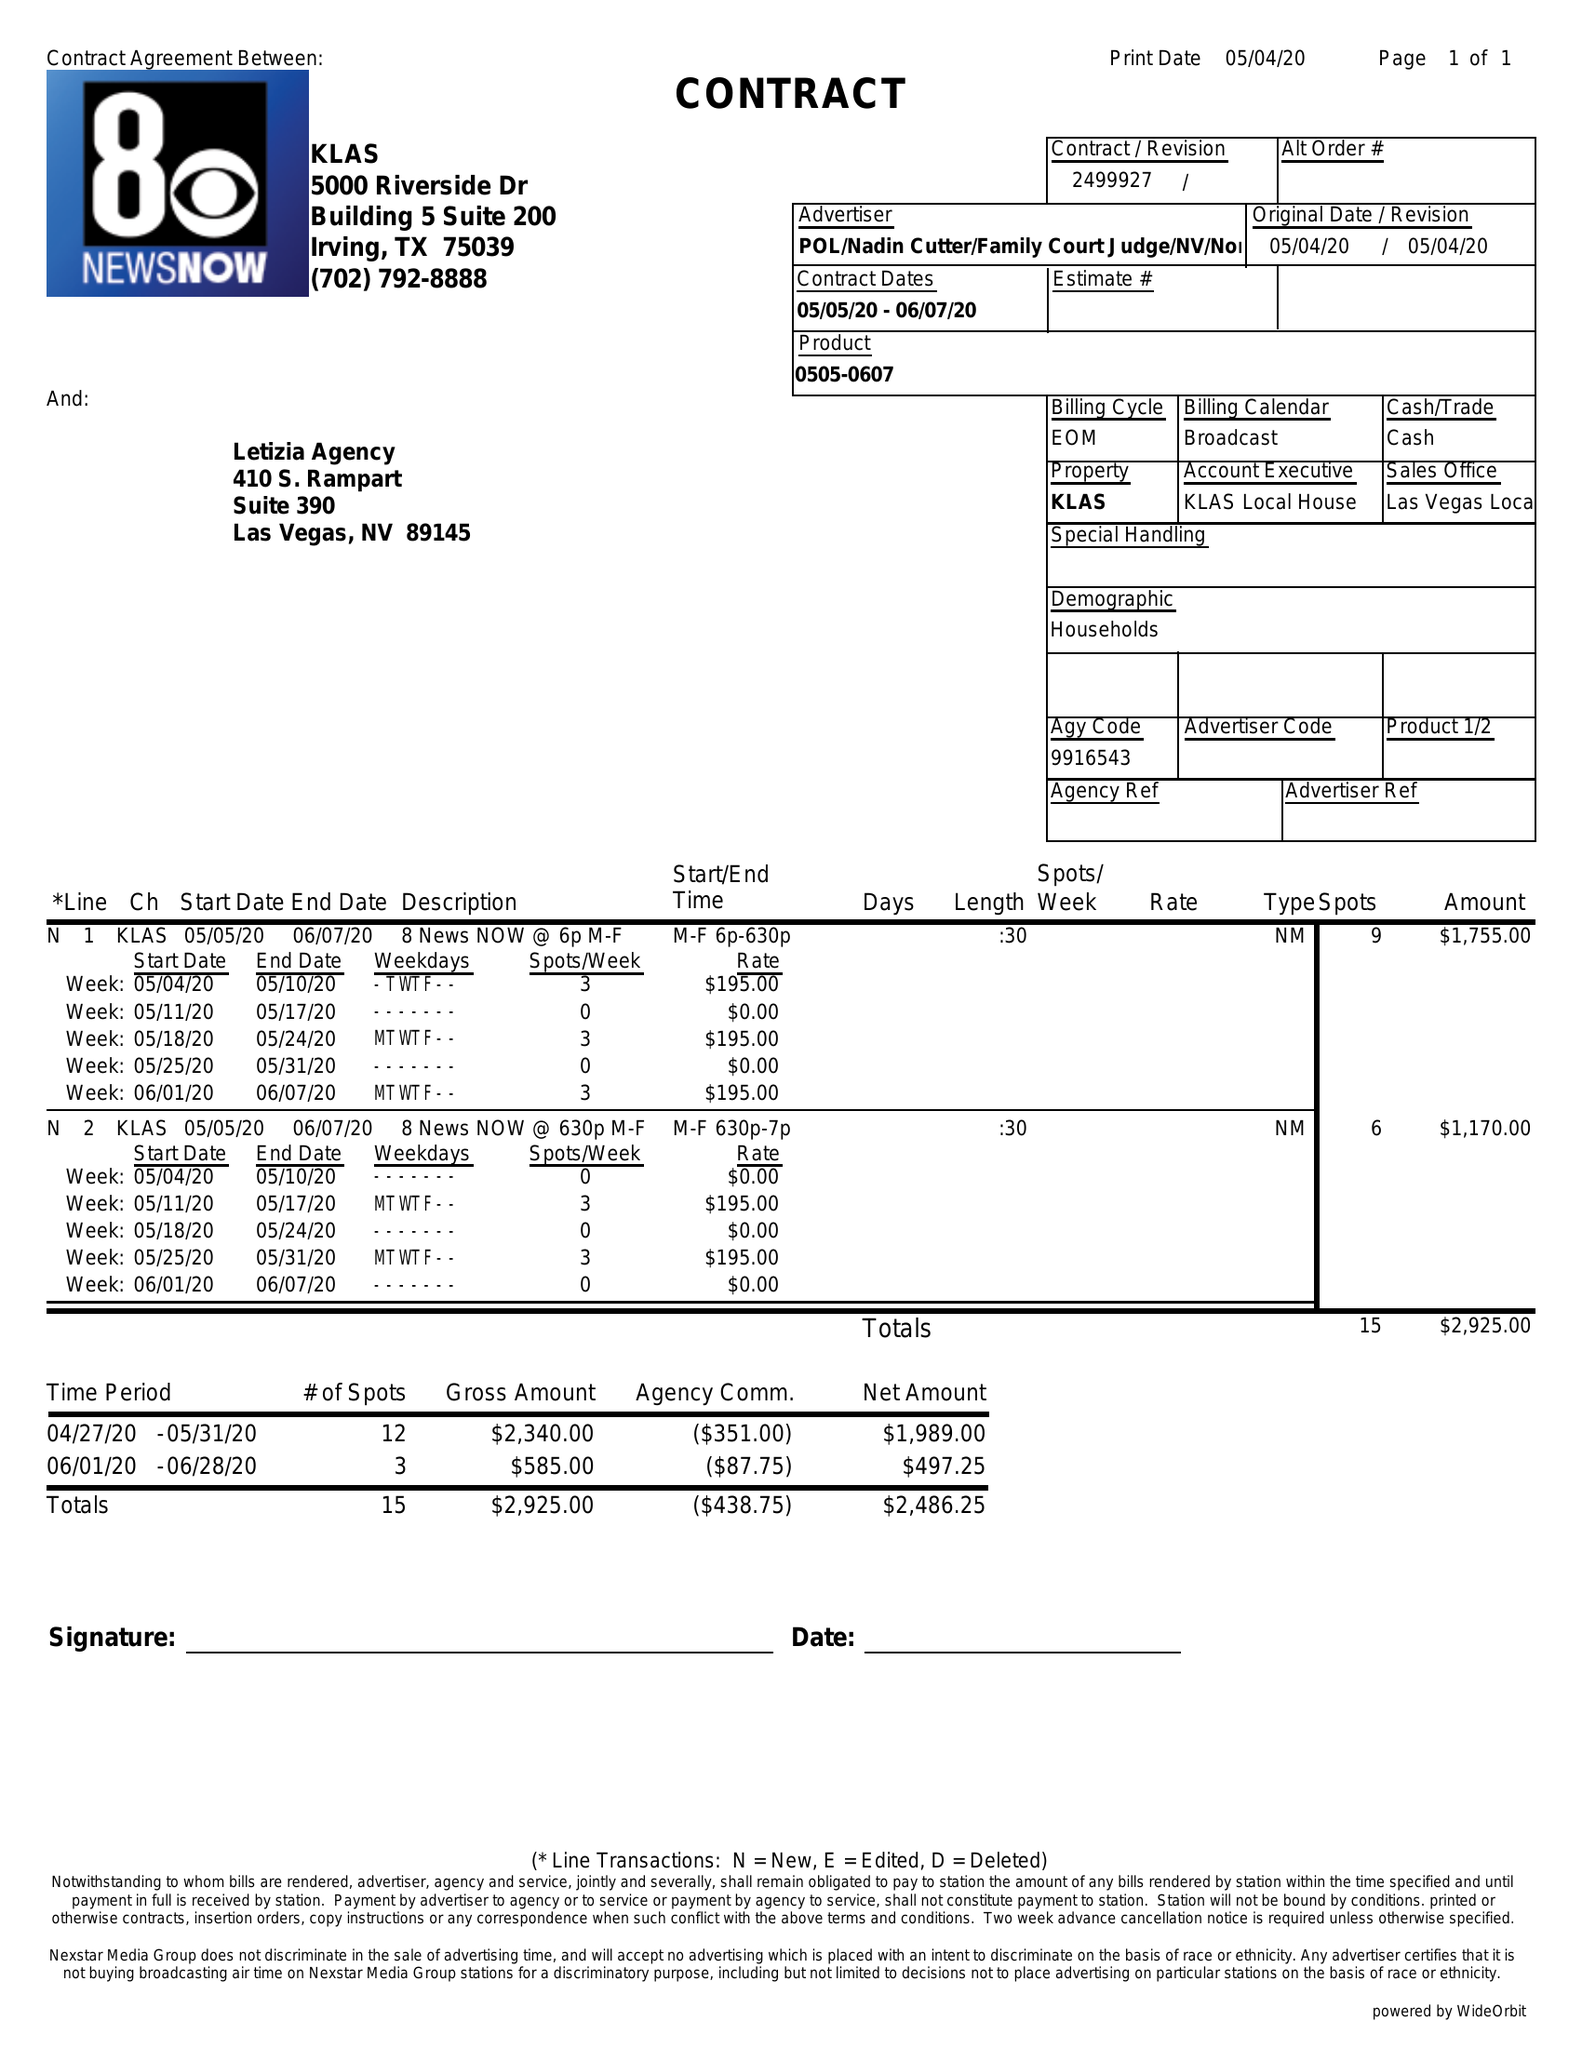What is the value for the gross_amount?
Answer the question using a single word or phrase. 2925.00 